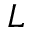<formula> <loc_0><loc_0><loc_500><loc_500>L</formula> 